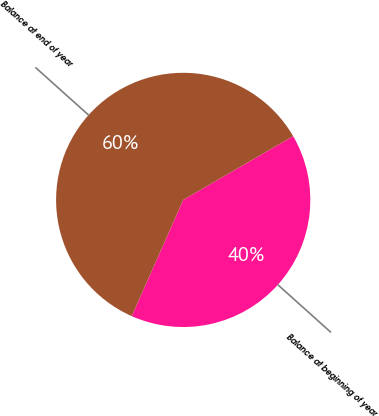Convert chart. <chart><loc_0><loc_0><loc_500><loc_500><pie_chart><fcel>Balance at beginning of year<fcel>Balance at end of year<nl><fcel>40.0%<fcel>60.0%<nl></chart> 